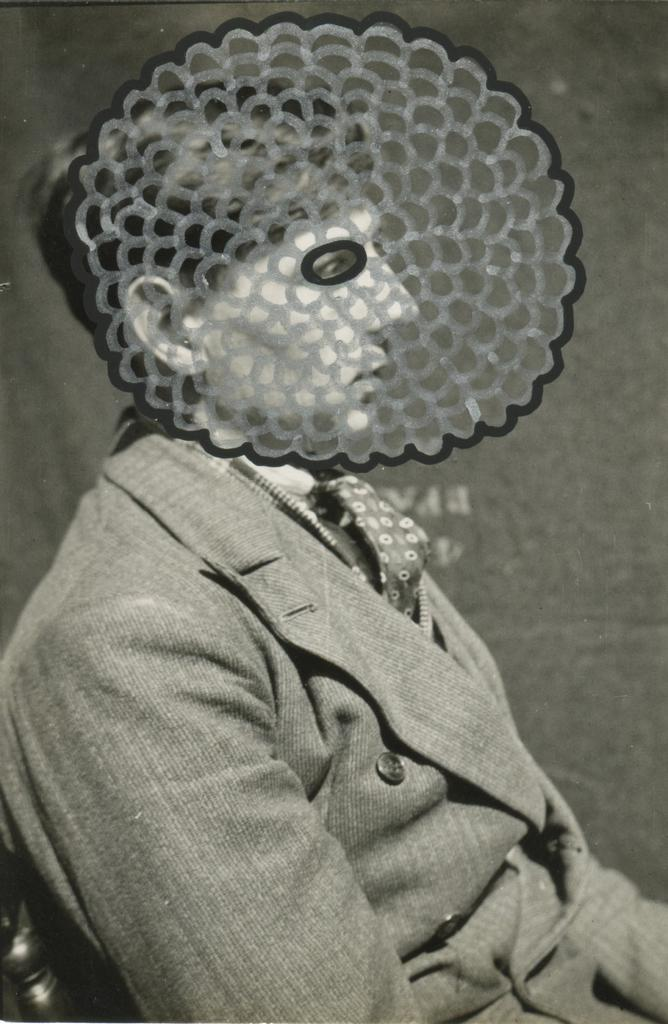What is the man in the image doing? The man is sitting in the image. What is the man wearing? The man is wearing a suit. What else can be seen in the image besides the man? There is a drawing in the image. What type of cemetery can be seen in the background of the image? There is no cemetery present in the image; it only features a man sitting and a drawing. 